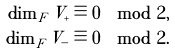<formula> <loc_0><loc_0><loc_500><loc_500>\dim _ { F } V _ { + } \equiv 0 \mod 2 , \\ \dim _ { F } V _ { - } \equiv 0 \mod 2 .</formula> 